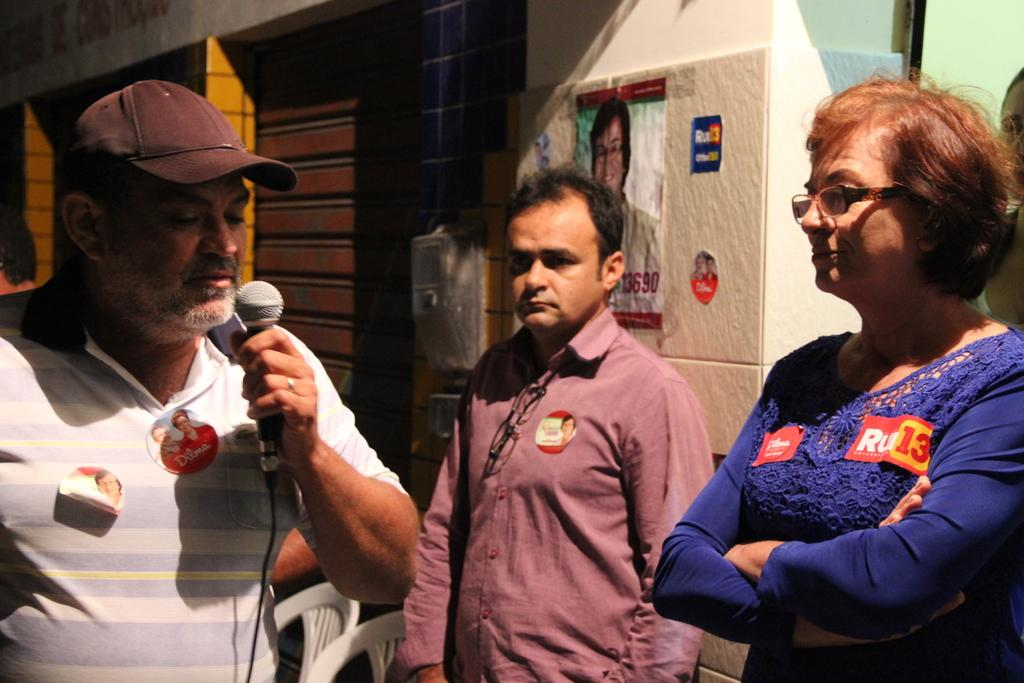How many people are in the image? There are three people in the image. Can you describe the appearance of one of the people? One of the people is a woman wearing a blue shirt. What is one of the men holding in the image? One of the men is holding a microphone. How many rabbits can be seen blowing bubbles in the image? There are no rabbits or bubbles present in the image. 